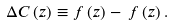Convert formula to latex. <formula><loc_0><loc_0><loc_500><loc_500>\Delta C \left ( z \right ) \equiv f \left ( z \right ) - \, f \left ( z \right ) .</formula> 